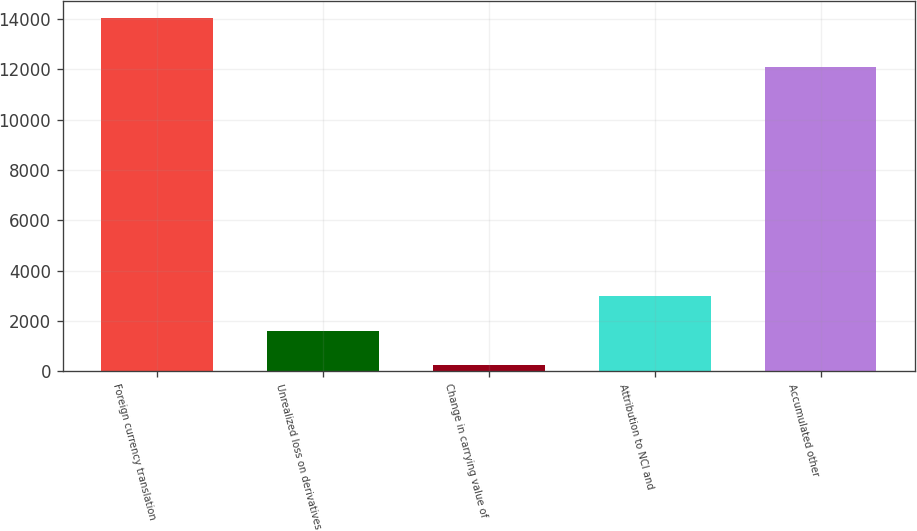Convert chart. <chart><loc_0><loc_0><loc_500><loc_500><bar_chart><fcel>Foreign currency translation<fcel>Unrealized loss on derivatives<fcel>Change in carrying value of<fcel>Attribution to NCI and<fcel>Accumulated other<nl><fcel>14027<fcel>1611.5<fcel>232<fcel>2991<fcel>12100<nl></chart> 